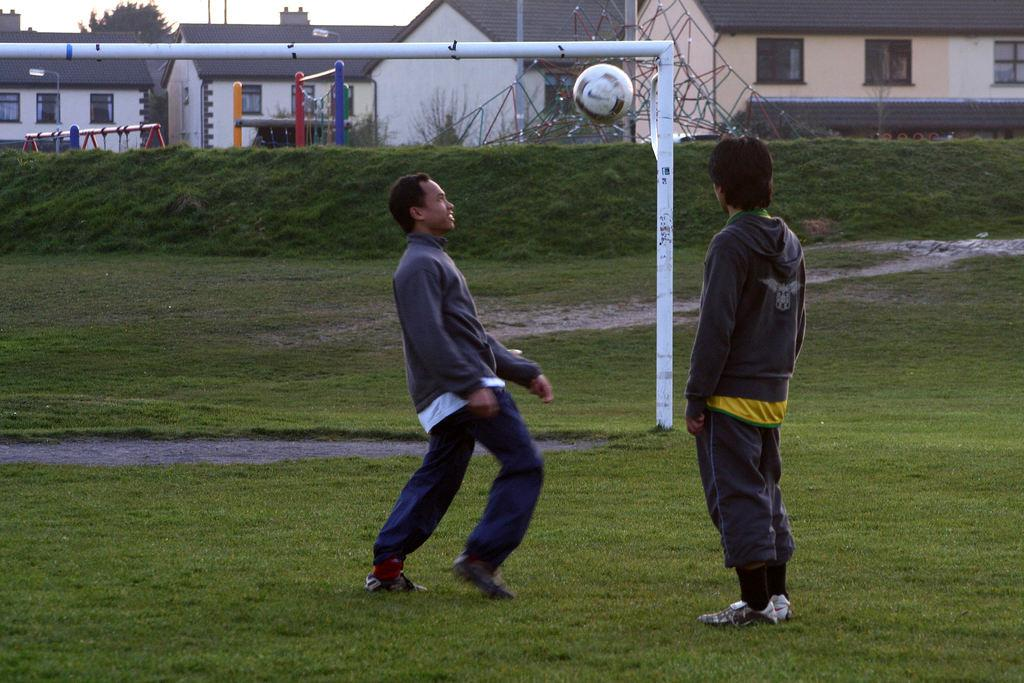How many people are in the image? There are two people in the center of the image. What objects can be seen in the image besides the people? There is a rod, a ball, sheds, a tree, and grass visible in the image. What is the background of the image? The background of the image includes sheds, a tree, and the sky. What is the ground made of in the image? The ground at the bottom of the image is made of grass. What chess piece is the person on the left playing in the image? There is no chessboard or chess pieces present in the image. How are the people in the image sorting the items on the rod? There is no indication in the image that the people are sorting any items on the rod. 